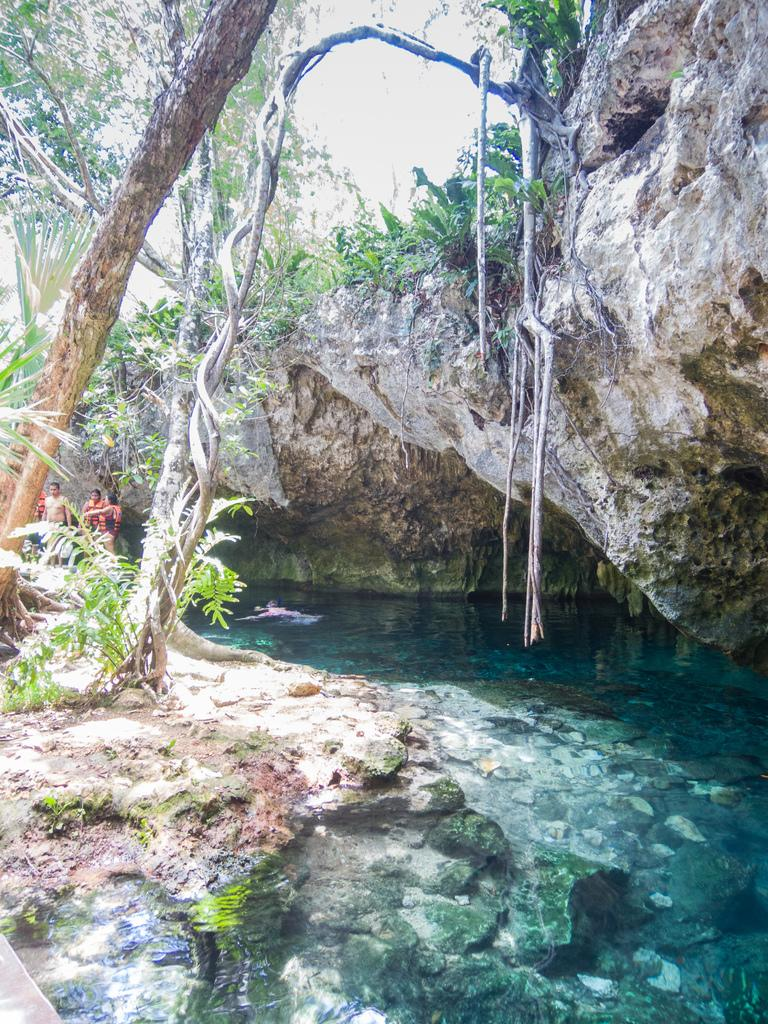What is the main setting of the image? The image is taken near a cave. What type of natural features can be seen in the image? There are rocks, trees, water, and plants visible in the image. Can you describe the tree in the image? The tree has aerial roots. Are there any people present in the image? Yes, there are people standing in the background of the image. What type of punishment is being administered to the people in the image? There is no indication of any punishment being administered in the image; it simply shows people standing near a cave with various natural features. What kind of apparatus is being used by the people in the image? There is no apparatus visible in the image; the people are simply standing in the background. 